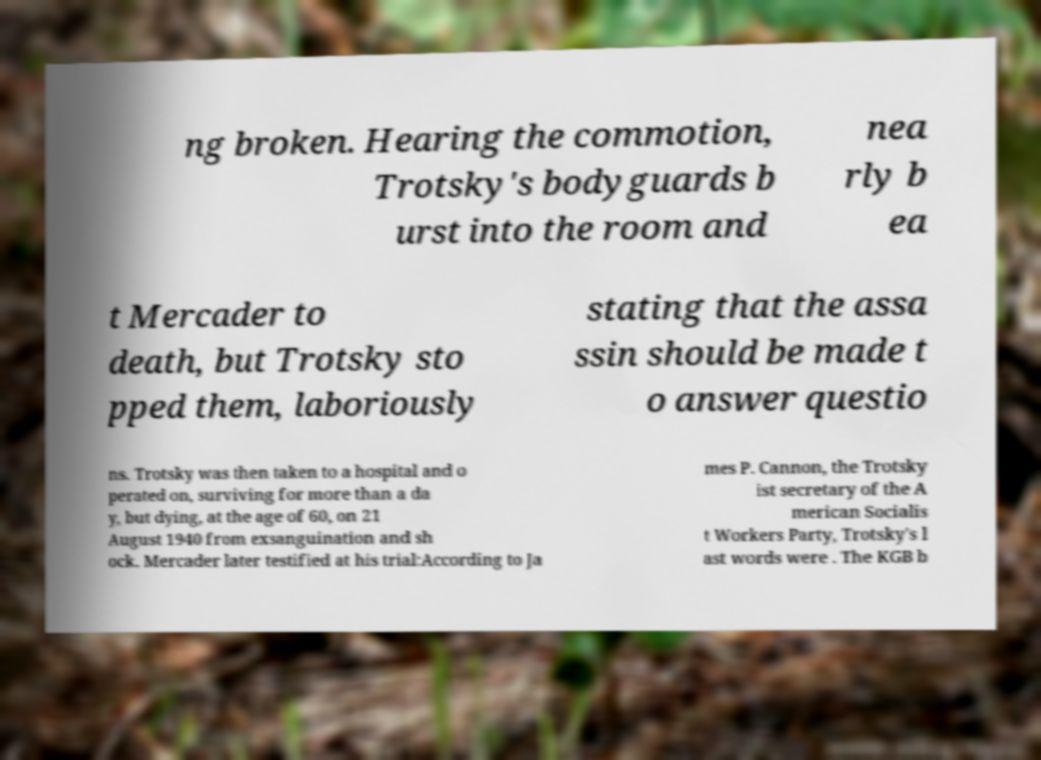Can you read and provide the text displayed in the image?This photo seems to have some interesting text. Can you extract and type it out for me? ng broken. Hearing the commotion, Trotsky's bodyguards b urst into the room and nea rly b ea t Mercader to death, but Trotsky sto pped them, laboriously stating that the assa ssin should be made t o answer questio ns. Trotsky was then taken to a hospital and o perated on, surviving for more than a da y, but dying, at the age of 60, on 21 August 1940 from exsanguination and sh ock. Mercader later testified at his trial:According to Ja mes P. Cannon, the Trotsky ist secretary of the A merican Socialis t Workers Party, Trotsky's l ast words were . The KGB b 